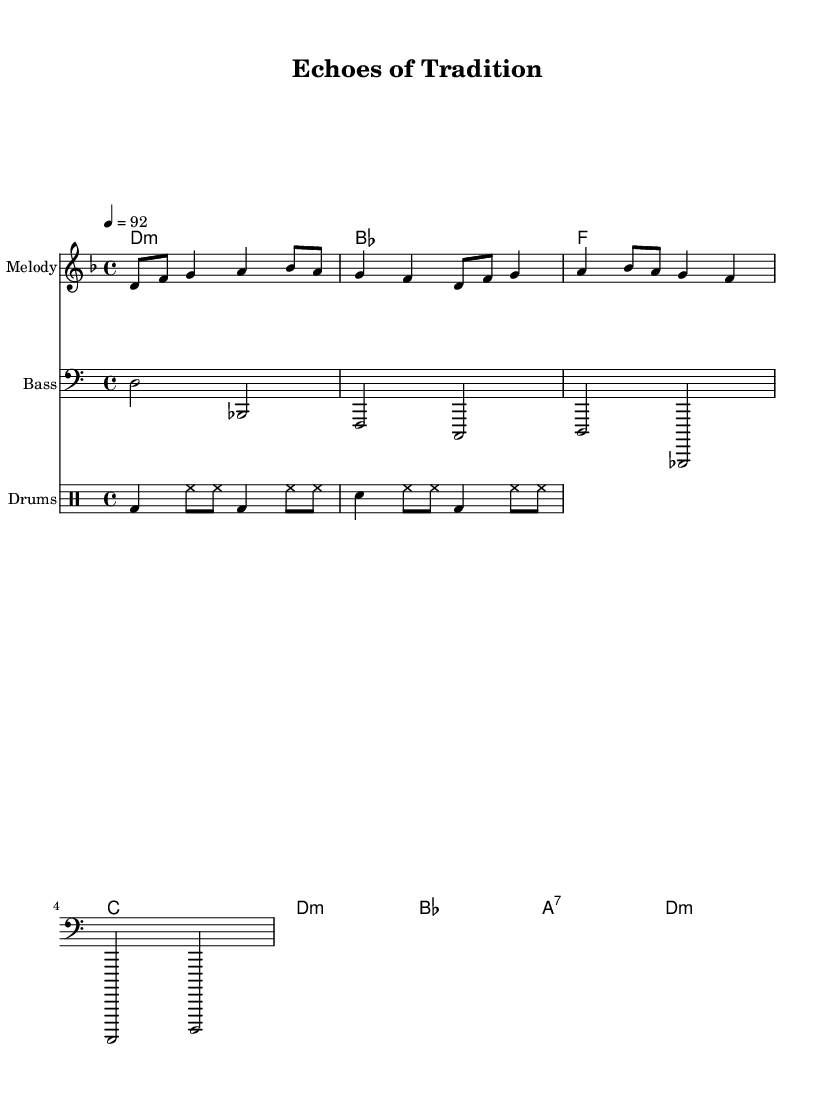What is the key signature of this music? The key signature is indicated by the presence of one flat (B♭) on the staff. This means that the key is D minor.
Answer: D minor What is the time signature of this music? The time signature is at the beginning of the score, indicated as 4/4. This means there are four beats in a measure.
Answer: 4/4 What is the tempo marking of this piece? The tempo is indicated by the text “4 = 92”, meaning that there are 92 beats per minute.
Answer: 92 How many measures are present in the melody? The melody line has eight distinct measures, which can be counted visually by identifying the vertical bar lines in the notation.
Answer: Eight What instruments are featured in this sheet music? The sheet music includes a melody staff, a bass staff, and a drum staff, representing different instruments playing together.
Answer: Melody, Bass, Drums What type of harmony is primarily used in this piece? The harmony section predominantly features minor chords, evidenced by symbols such as "d:m" and others that follow the minor chord format.
Answer: Minor What rhythmic pattern is established by the drum section? The drum pattern combines kick drum (bd), snare (sn), and hi-hat (hh) which establishes a consistent hip-hop beat.
Answer: Kick-Snare-Hi-Hat 